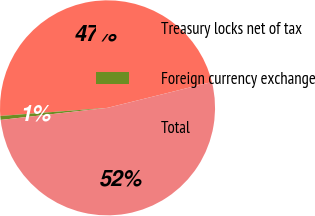Convert chart. <chart><loc_0><loc_0><loc_500><loc_500><pie_chart><fcel>Treasury locks net of tax<fcel>Foreign currency exchange<fcel>Total<nl><fcel>47.34%<fcel>0.59%<fcel>52.07%<nl></chart> 